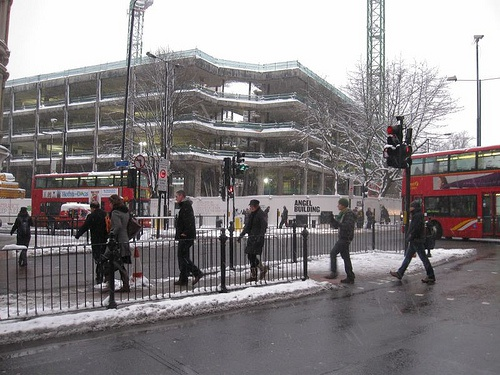Describe the objects in this image and their specific colors. I can see bus in gray, black, maroon, and brown tones, bus in gray, black, maroon, and darkgray tones, people in gray, black, and darkgray tones, people in gray, black, and darkgray tones, and people in gray, black, and darkgray tones in this image. 